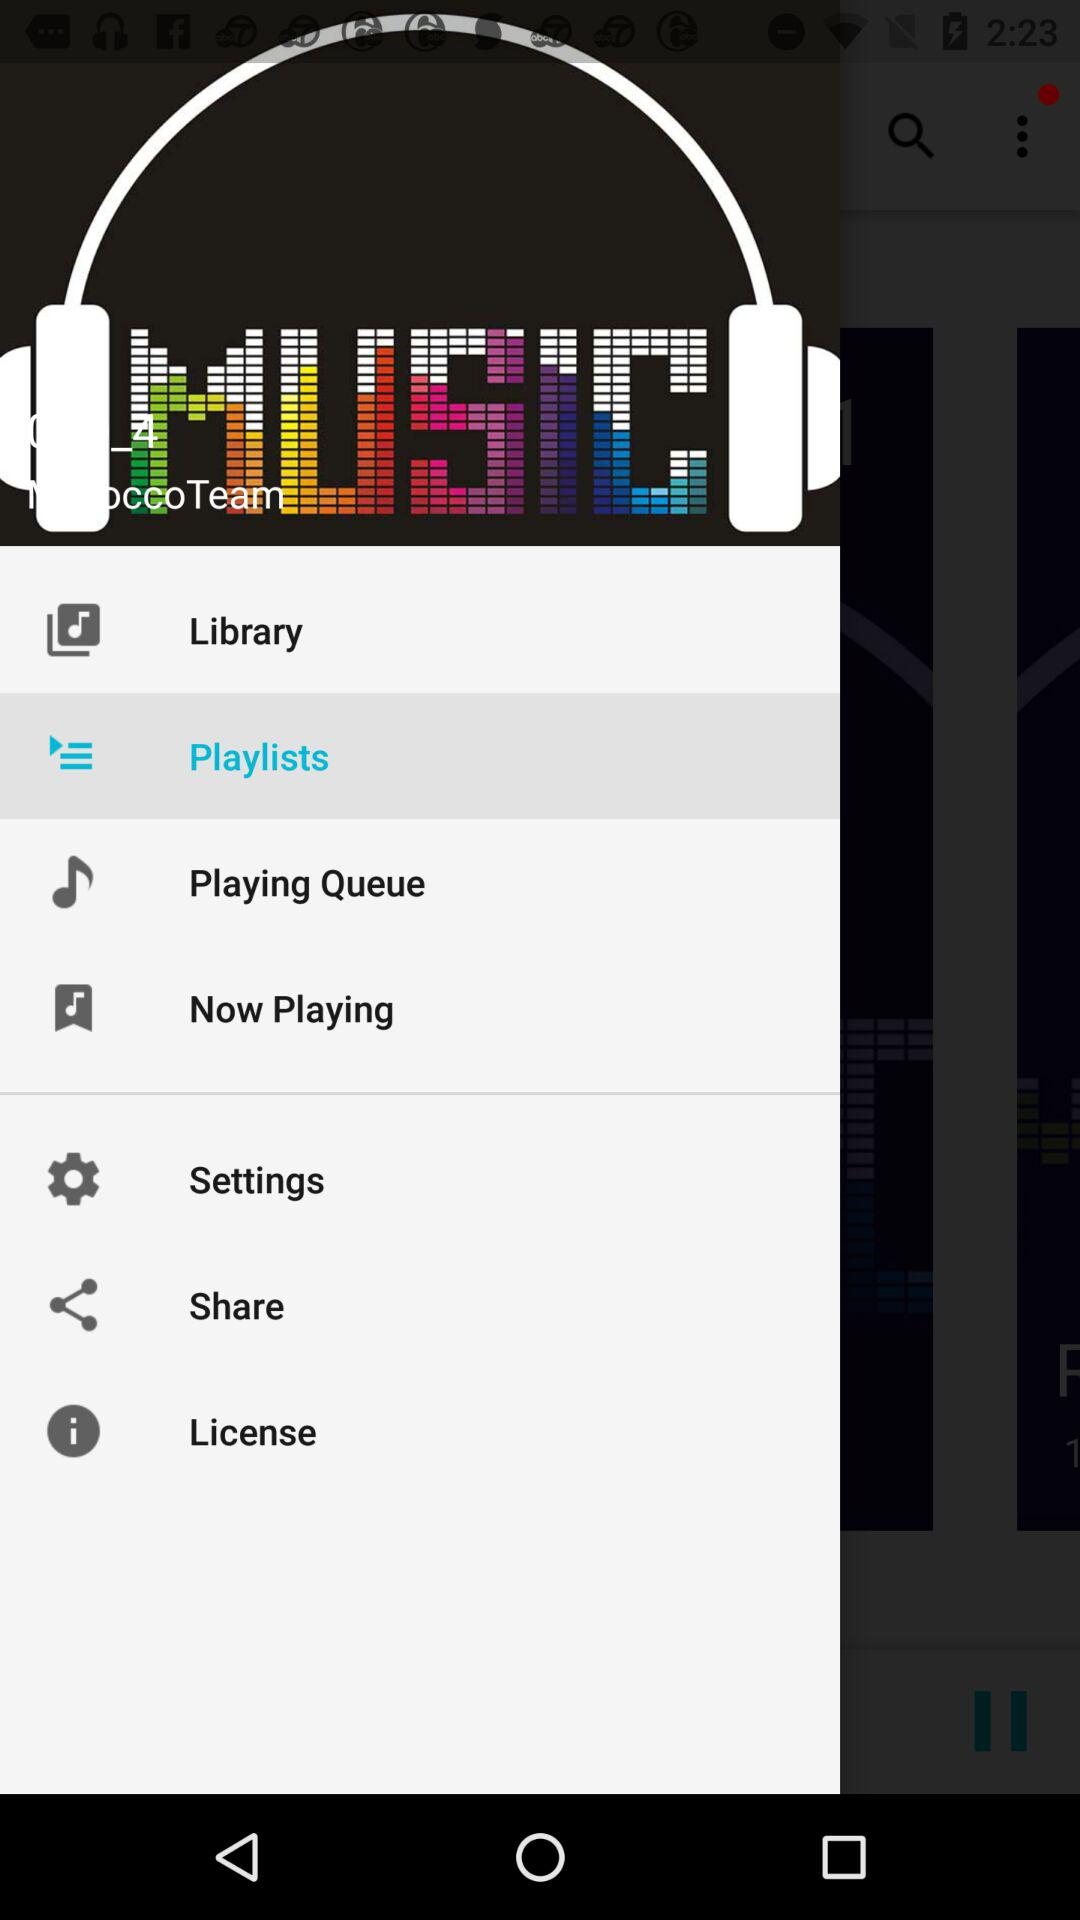Which item is selected? The selected item is "Playlists". 